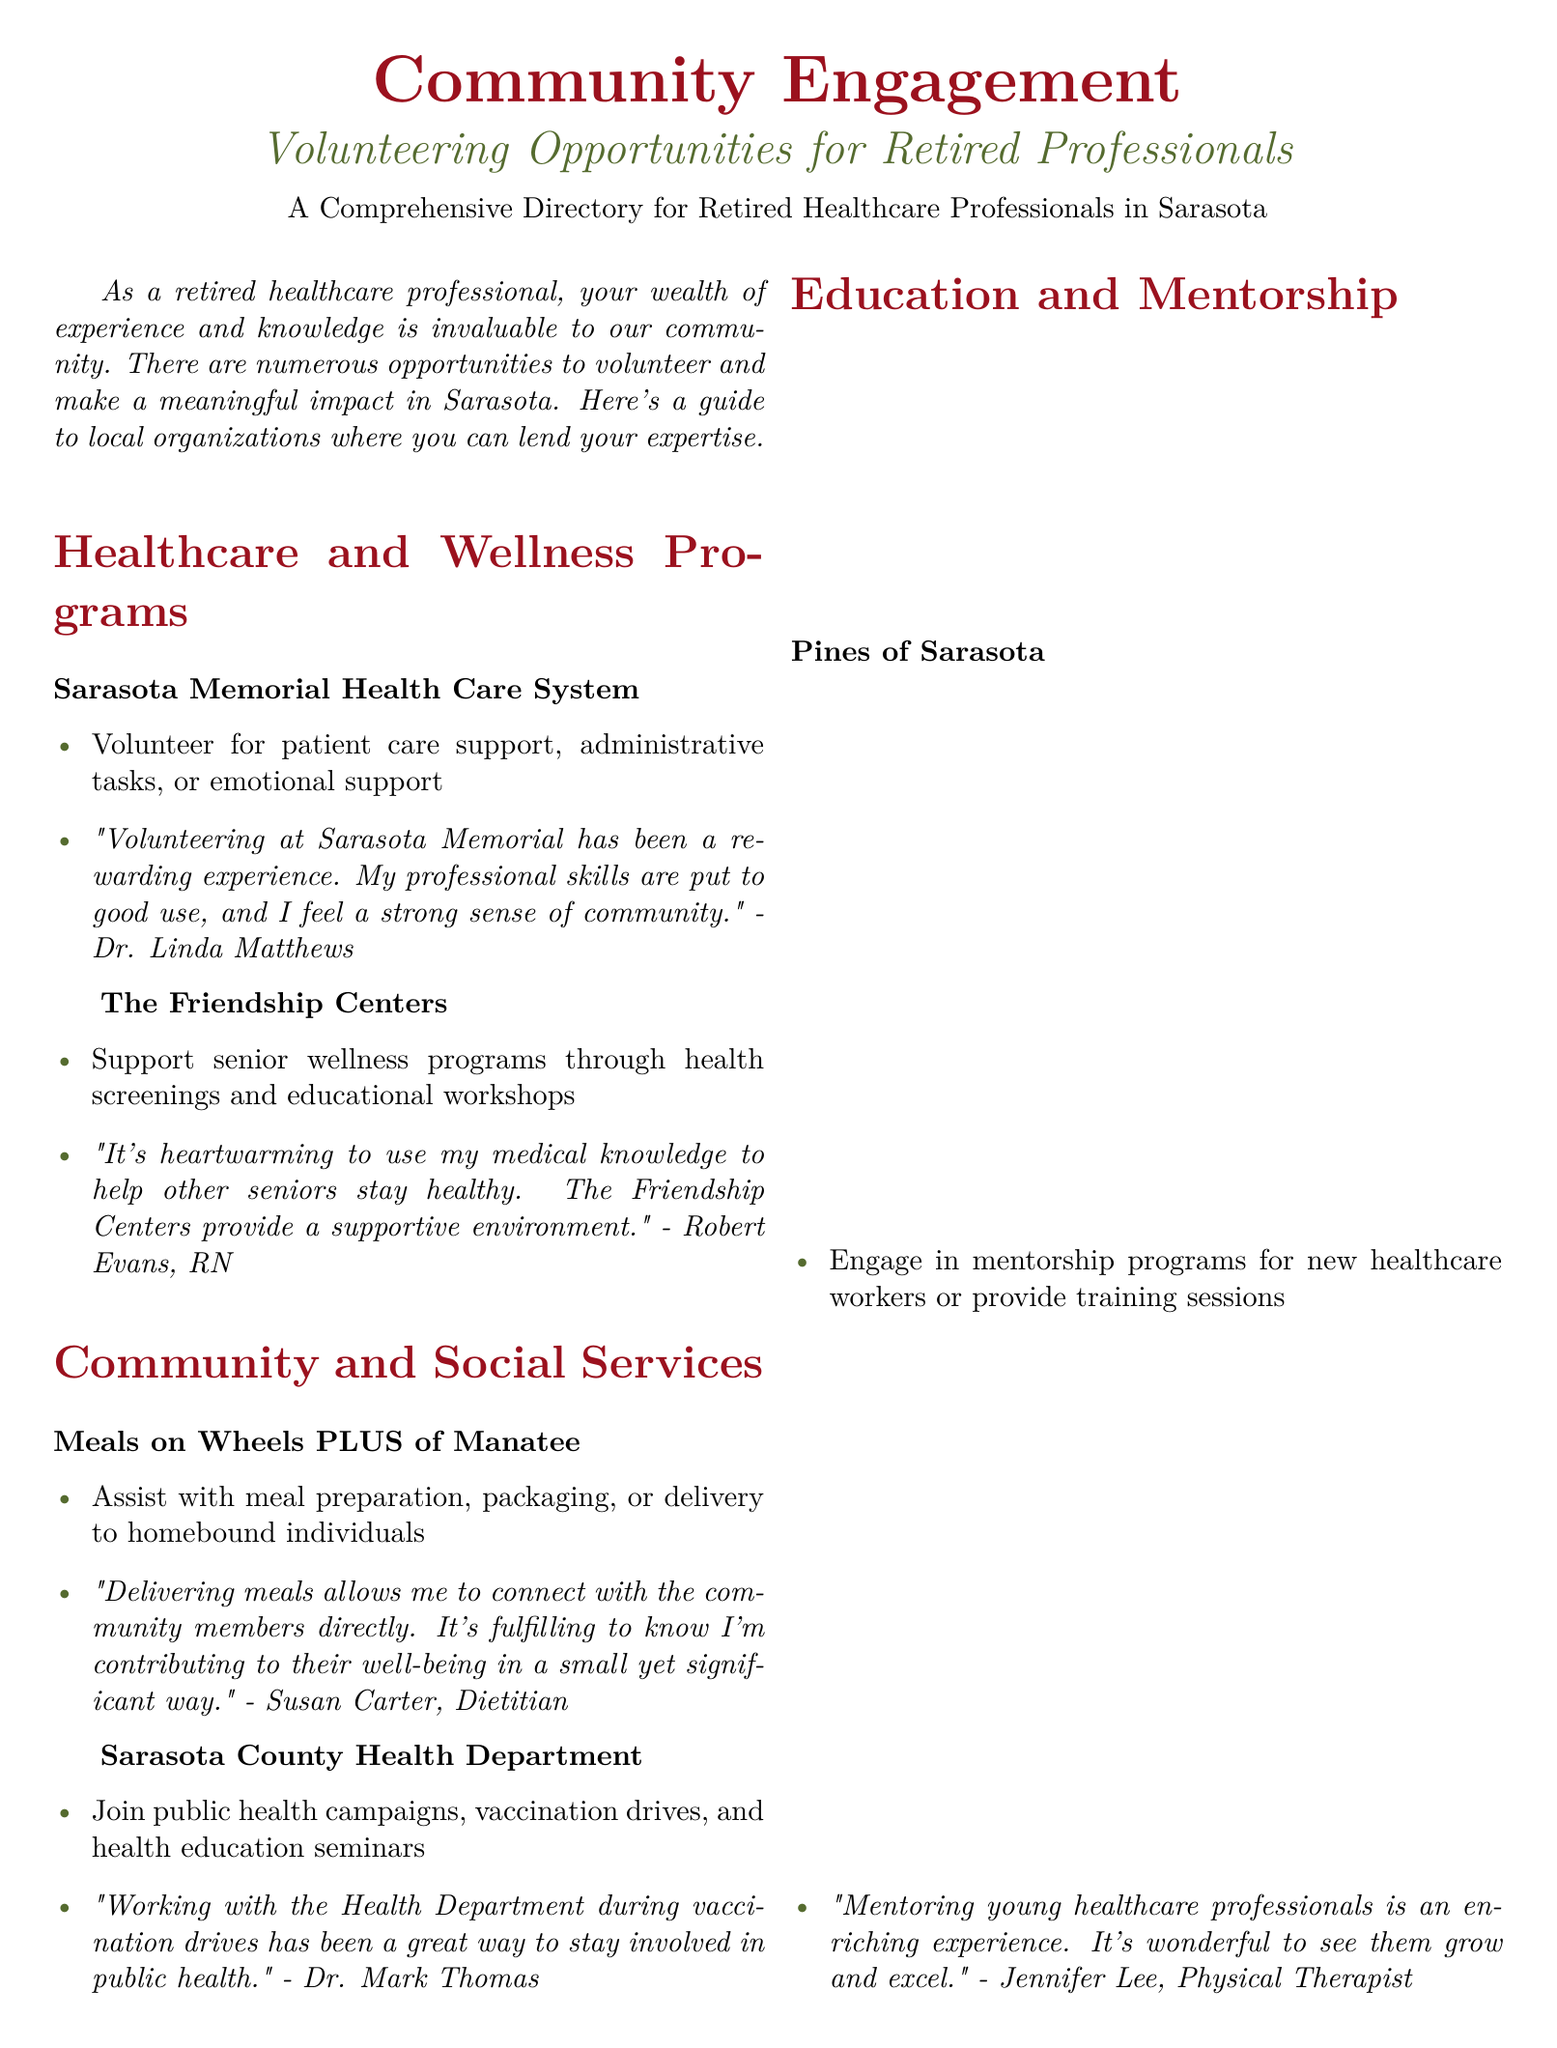What is the main audience of the document? The document specifically targets retired healthcare professionals in Sarasota.
Answer: Retired healthcare professionals Which organization offers mentorship programs for new healthcare workers? Pines of Sarasota is identified in the document as providing mentorship programs for new healthcare workers.
Answer: Pines of Sarasota How many healthcare and wellness programs are mentioned? The document lists two healthcare and wellness programs: Sarasota Memorial Health Care System and The Friendship Centers.
Answer: Two What type of support can volunteers provide at Sarasota Memorial Health Care System? Volunteers can assist with patient care support, administrative tasks, or emotional support.
Answer: Patient care support Which local organization provides meal delivery services? Meals on Wheels PLUS of Manatee is noted in the document as providing meal delivery services.
Answer: Meals on Wheels PLUS of Manatee What is a cited positive experience from a volunteer at The Friendship Centers? Robert Evans, RN, states that using his medical knowledge to help seniors is a heartwarming experience.
Answer: Heartwarming experience What type of community services does the Sarasota County Health Department involve volunteers in? Volunteers can join public health campaigns, vaccination drives, and health education seminars.
Answer: Public health campaigns What is the tagline for Piccolo Italian Market & Deli? The tagline emphasizes its role as a community hub for both volunteering and great Italian cuisine.
Answer: Your Community Hub for Volunteering and Great Italian Cuisine 